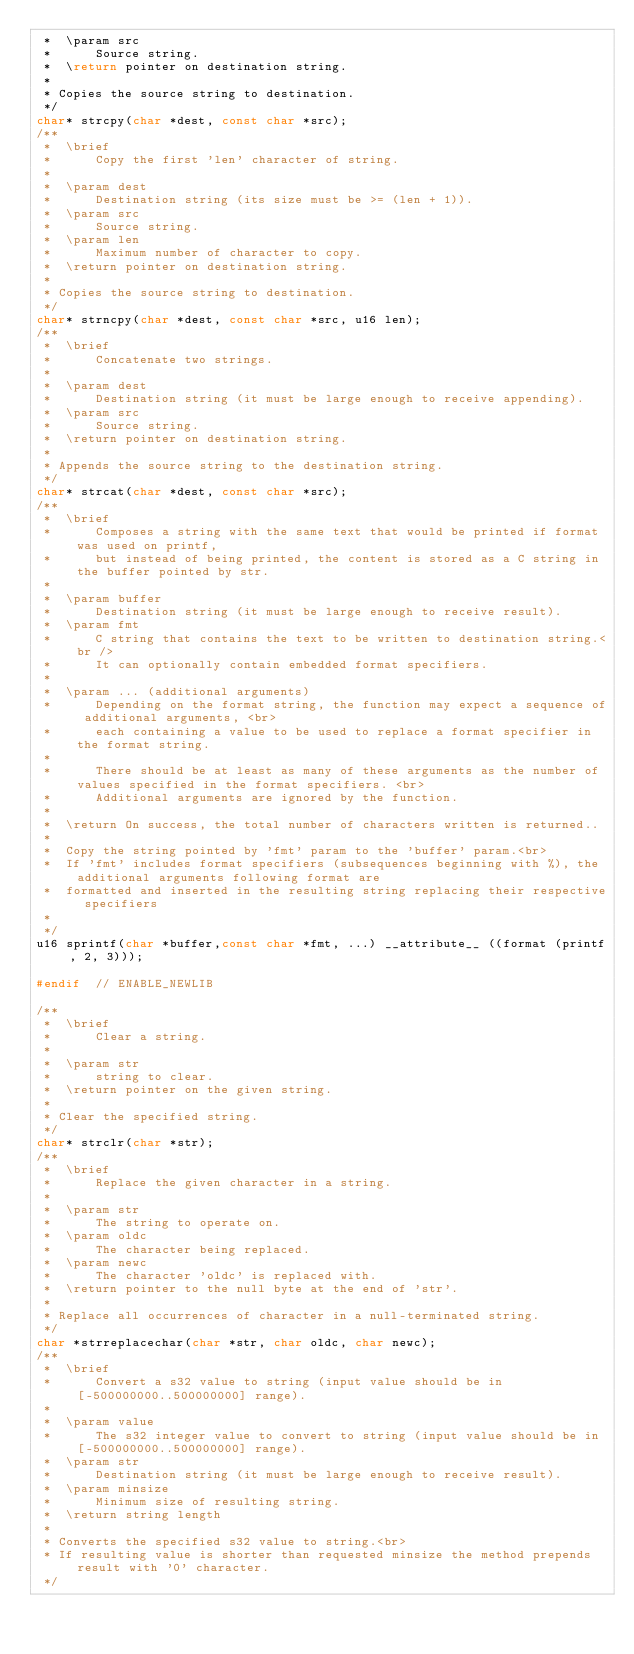Convert code to text. <code><loc_0><loc_0><loc_500><loc_500><_C_> *  \param src
 *      Source string.
 *  \return pointer on destination string.
 *
 * Copies the source string to destination.
 */
char* strcpy(char *dest, const char *src);
/**
 *  \brief
 *      Copy the first 'len' character of string.
 *
 *  \param dest
 *      Destination string (its size must be >= (len + 1)).
 *  \param src
 *      Source string.
 *  \param len
 *      Maximum number of character to copy.
 *  \return pointer on destination string.
 *
 * Copies the source string to destination.
 */
char* strncpy(char *dest, const char *src, u16 len);
/**
 *  \brief
 *      Concatenate two strings.
 *
 *  \param dest
 *      Destination string (it must be large enough to receive appending).
 *  \param src
 *      Source string.
 *  \return pointer on destination string.
 *
 * Appends the source string to the destination string.
 */
char* strcat(char *dest, const char *src);
/**
 *  \brief
 *      Composes a string with the same text that would be printed if format was used on printf,
 *      but instead of being printed, the content is stored as a C string in the buffer pointed by str.
 *
 *  \param buffer
 *      Destination string (it must be large enough to receive result).
 *  \param fmt
 *      C string that contains the text to be written to destination string.<br />
 *      It can optionally contain embedded format specifiers.
 *
 *  \param ... (additional arguments)
 *      Depending on the format string, the function may expect a sequence of additional arguments, <br>
 *      each containing a value to be used to replace a format specifier in the format string.
 *
 *      There should be at least as many of these arguments as the number of values specified in the format specifiers. <br>
 *      Additional arguments are ignored by the function.
 *
 *  \return On success, the total number of characters written is returned..
 *
 *  Copy the string pointed by 'fmt' param to the 'buffer' param.<br>
 *  If 'fmt' includes format specifiers (subsequences beginning with %), the additional arguments following format are
 *  formatted and inserted in the resulting string replacing their respective specifiers
 *
 */
u16 sprintf(char *buffer,const char *fmt, ...) __attribute__ ((format (printf, 2, 3)));

#endif  // ENABLE_NEWLIB

/**
 *  \brief
 *      Clear a string.
 *
 *  \param str
 *      string to clear.
 *  \return pointer on the given string.
 *
 * Clear the specified string.
 */
char* strclr(char *str);
/**
 *  \brief
 *      Replace the given character in a string.
 *
 *  \param str
 *      The string to operate on.
 *  \param oldc
 *      The character being replaced.
 *  \param newc
 *      The character 'oldc' is replaced with.
 *  \return pointer to the null byte at the end of 'str'.
 *
 * Replace all occurrences of character in a null-terminated string.
 */
char *strreplacechar(char *str, char oldc, char newc);
/**
 *  \brief
 *      Convert a s32 value to string (input value should be in [-500000000..500000000] range).
 *
 *  \param value
 *      The s32 integer value to convert to string (input value should be in [-500000000..500000000] range).
 *  \param str
 *      Destination string (it must be large enough to receive result).
 *  \param minsize
 *      Minimum size of resulting string.
 *  \return string length
 *
 * Converts the specified s32 value to string.<br>
 * If resulting value is shorter than requested minsize the method prepends result with '0' character.
 */</code> 